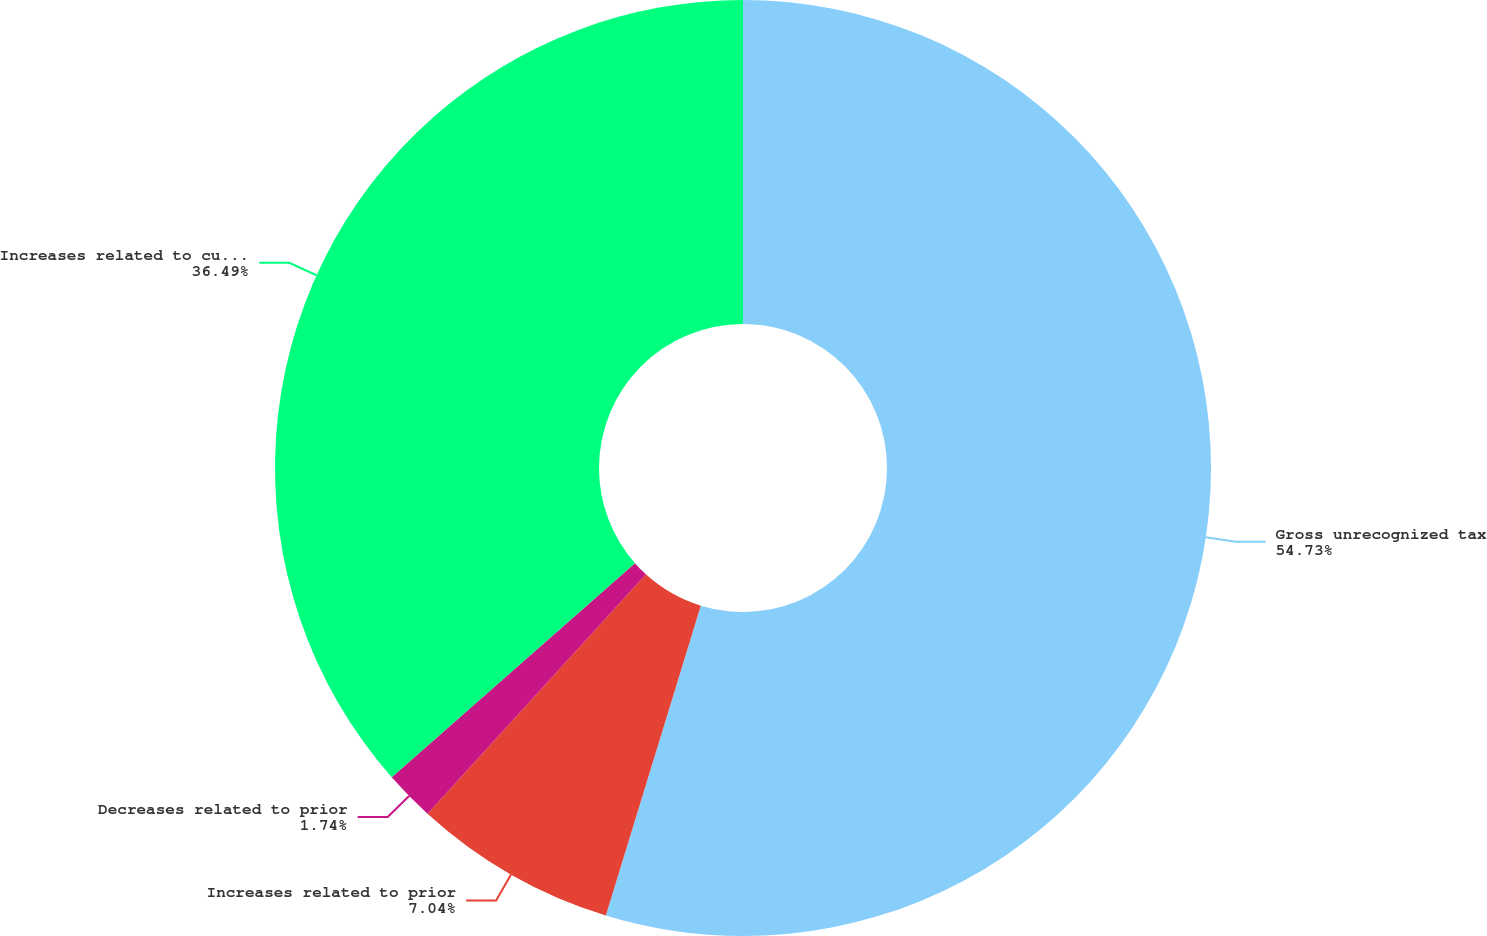Convert chart to OTSL. <chart><loc_0><loc_0><loc_500><loc_500><pie_chart><fcel>Gross unrecognized tax<fcel>Increases related to prior<fcel>Decreases related to prior<fcel>Increases related to current<nl><fcel>54.74%<fcel>7.04%<fcel>1.74%<fcel>36.49%<nl></chart> 